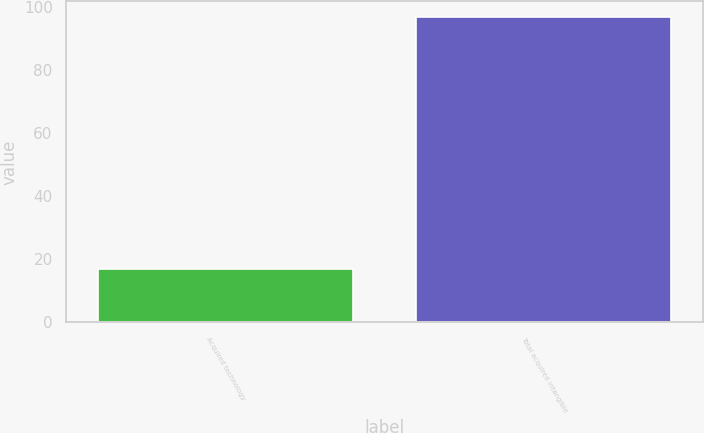Convert chart to OTSL. <chart><loc_0><loc_0><loc_500><loc_500><bar_chart><fcel>Acquired technology<fcel>Total acquired intangible<nl><fcel>17<fcel>97<nl></chart> 